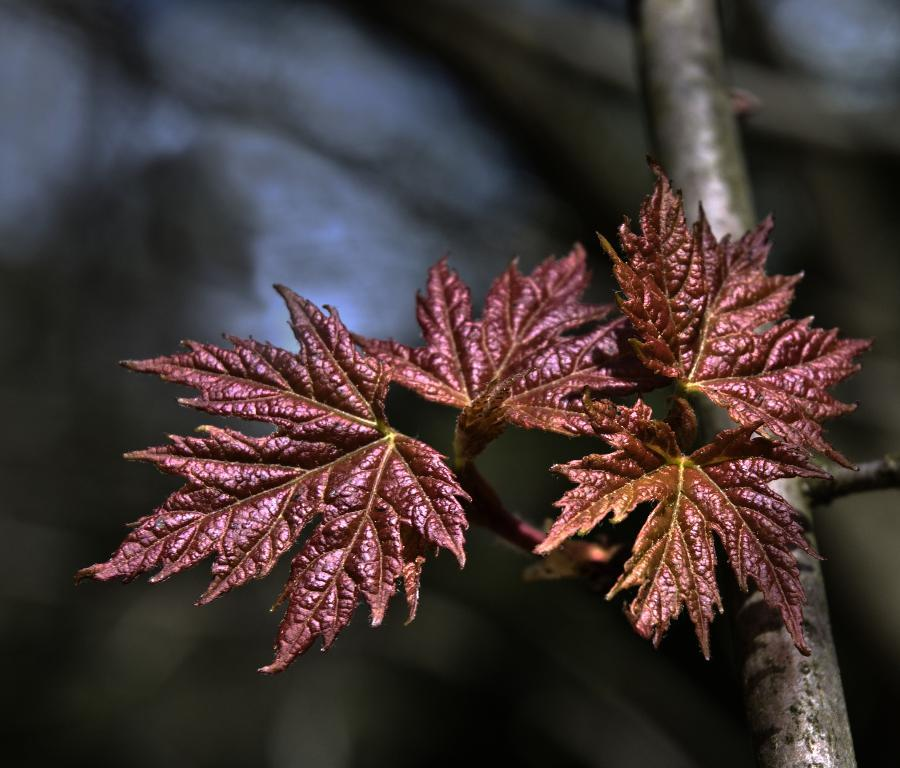What type of vegetation can be seen in the image? There are leaves in the image. What is the color of the leaves? The leaves are brown in color. Can you describe the background of the image? The background of the image is blurred. Is there a chain attached to the leaves in the image? No, there is no chain present in the image. Can you see any flames in the image? No, there are no flames present in the image. 